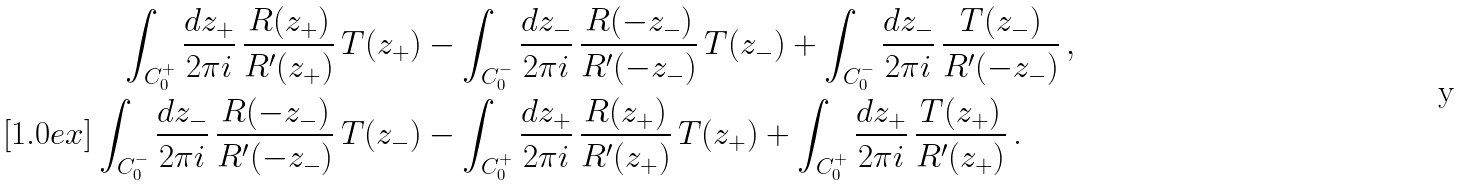Convert formula to latex. <formula><loc_0><loc_0><loc_500><loc_500>\int _ { C _ { 0 } ^ { + } } \frac { d z _ { + } } { 2 \pi i } \, \frac { R ( z _ { + } ) } { R ^ { \prime } ( z _ { + } ) } \, T ( z _ { + } ) & - \int _ { C _ { 0 } ^ { - } } \frac { d z _ { - } } { 2 \pi i } \, \frac { R ( - z _ { - } ) } { R ^ { \prime } ( - z _ { - } ) } \, T ( z _ { - } ) + \int _ { C _ { 0 } ^ { - } } \frac { d z _ { - } } { 2 \pi i } \, \frac { T ( z _ { - } ) } { R ^ { \prime } ( - z _ { - } ) } \, , \\ [ 1 . 0 e x ] \int _ { C _ { 0 } ^ { - } } \frac { d z _ { - } } { 2 \pi i } \, \frac { R ( - z _ { - } ) } { R ^ { \prime } ( - z _ { - } ) } \, T ( z _ { - } ) & - \int _ { C _ { 0 } ^ { + } } \frac { d z _ { + } } { 2 \pi i } \, \frac { R ( z _ { + } ) } { R ^ { \prime } ( z _ { + } ) } \, T ( z _ { + } ) + \int _ { C _ { 0 } ^ { + } } \frac { d z _ { + } } { 2 \pi i } \, \frac { T ( z _ { + } ) } { R ^ { \prime } ( z _ { + } ) } \, .</formula> 